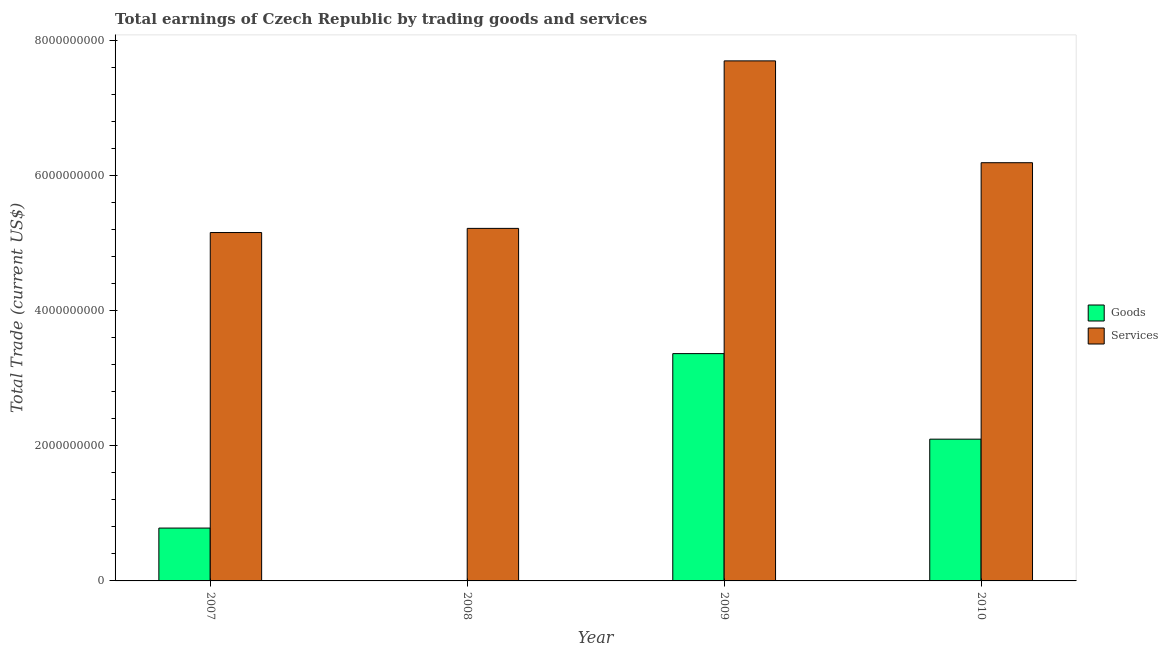How many different coloured bars are there?
Offer a very short reply. 2. Are the number of bars per tick equal to the number of legend labels?
Provide a short and direct response. No. Are the number of bars on each tick of the X-axis equal?
Ensure brevity in your answer.  No. How many bars are there on the 4th tick from the left?
Your answer should be very brief. 2. How many bars are there on the 3rd tick from the right?
Provide a succinct answer. 1. What is the amount earned by trading services in 2010?
Give a very brief answer. 6.19e+09. Across all years, what is the maximum amount earned by trading goods?
Your answer should be compact. 3.37e+09. Across all years, what is the minimum amount earned by trading services?
Make the answer very short. 5.16e+09. What is the total amount earned by trading services in the graph?
Keep it short and to the point. 2.43e+1. What is the difference between the amount earned by trading services in 2007 and that in 2010?
Give a very brief answer. -1.03e+09. What is the difference between the amount earned by trading goods in 2008 and the amount earned by trading services in 2009?
Offer a terse response. -3.37e+09. What is the average amount earned by trading services per year?
Keep it short and to the point. 6.07e+09. In how many years, is the amount earned by trading goods greater than 6000000000 US$?
Provide a succinct answer. 0. What is the ratio of the amount earned by trading services in 2007 to that in 2010?
Your response must be concise. 0.83. What is the difference between the highest and the second highest amount earned by trading goods?
Make the answer very short. 1.27e+09. What is the difference between the highest and the lowest amount earned by trading services?
Your response must be concise. 2.54e+09. In how many years, is the amount earned by trading goods greater than the average amount earned by trading goods taken over all years?
Offer a terse response. 2. Is the sum of the amount earned by trading services in 2007 and 2009 greater than the maximum amount earned by trading goods across all years?
Your answer should be compact. Yes. How many years are there in the graph?
Make the answer very short. 4. What is the difference between two consecutive major ticks on the Y-axis?
Ensure brevity in your answer.  2.00e+09. Are the values on the major ticks of Y-axis written in scientific E-notation?
Your response must be concise. No. Does the graph contain any zero values?
Your answer should be compact. Yes. What is the title of the graph?
Ensure brevity in your answer.  Total earnings of Czech Republic by trading goods and services. Does "Investment in Telecom" appear as one of the legend labels in the graph?
Offer a terse response. No. What is the label or title of the X-axis?
Provide a succinct answer. Year. What is the label or title of the Y-axis?
Your response must be concise. Total Trade (current US$). What is the Total Trade (current US$) in Goods in 2007?
Your response must be concise. 7.83e+08. What is the Total Trade (current US$) in Services in 2007?
Provide a short and direct response. 5.16e+09. What is the Total Trade (current US$) in Services in 2008?
Give a very brief answer. 5.22e+09. What is the Total Trade (current US$) in Goods in 2009?
Offer a very short reply. 3.37e+09. What is the Total Trade (current US$) of Services in 2009?
Your answer should be compact. 7.70e+09. What is the Total Trade (current US$) in Goods in 2010?
Your answer should be very brief. 2.10e+09. What is the Total Trade (current US$) in Services in 2010?
Ensure brevity in your answer.  6.19e+09. Across all years, what is the maximum Total Trade (current US$) in Goods?
Make the answer very short. 3.37e+09. Across all years, what is the maximum Total Trade (current US$) of Services?
Your response must be concise. 7.70e+09. Across all years, what is the minimum Total Trade (current US$) in Goods?
Make the answer very short. 0. Across all years, what is the minimum Total Trade (current US$) in Services?
Your answer should be compact. 5.16e+09. What is the total Total Trade (current US$) of Goods in the graph?
Give a very brief answer. 6.25e+09. What is the total Total Trade (current US$) in Services in the graph?
Give a very brief answer. 2.43e+1. What is the difference between the Total Trade (current US$) of Services in 2007 and that in 2008?
Make the answer very short. -6.16e+07. What is the difference between the Total Trade (current US$) in Goods in 2007 and that in 2009?
Offer a terse response. -2.58e+09. What is the difference between the Total Trade (current US$) in Services in 2007 and that in 2009?
Your response must be concise. -2.54e+09. What is the difference between the Total Trade (current US$) of Goods in 2007 and that in 2010?
Offer a terse response. -1.32e+09. What is the difference between the Total Trade (current US$) in Services in 2007 and that in 2010?
Your answer should be very brief. -1.03e+09. What is the difference between the Total Trade (current US$) in Services in 2008 and that in 2009?
Keep it short and to the point. -2.48e+09. What is the difference between the Total Trade (current US$) of Services in 2008 and that in 2010?
Your response must be concise. -9.72e+08. What is the difference between the Total Trade (current US$) of Goods in 2009 and that in 2010?
Keep it short and to the point. 1.27e+09. What is the difference between the Total Trade (current US$) in Services in 2009 and that in 2010?
Offer a very short reply. 1.51e+09. What is the difference between the Total Trade (current US$) of Goods in 2007 and the Total Trade (current US$) of Services in 2008?
Provide a succinct answer. -4.44e+09. What is the difference between the Total Trade (current US$) in Goods in 2007 and the Total Trade (current US$) in Services in 2009?
Provide a succinct answer. -6.92e+09. What is the difference between the Total Trade (current US$) of Goods in 2007 and the Total Trade (current US$) of Services in 2010?
Your answer should be compact. -5.41e+09. What is the difference between the Total Trade (current US$) in Goods in 2009 and the Total Trade (current US$) in Services in 2010?
Provide a short and direct response. -2.83e+09. What is the average Total Trade (current US$) in Goods per year?
Ensure brevity in your answer.  1.56e+09. What is the average Total Trade (current US$) of Services per year?
Offer a very short reply. 6.07e+09. In the year 2007, what is the difference between the Total Trade (current US$) in Goods and Total Trade (current US$) in Services?
Keep it short and to the point. -4.38e+09. In the year 2009, what is the difference between the Total Trade (current US$) of Goods and Total Trade (current US$) of Services?
Provide a succinct answer. -4.33e+09. In the year 2010, what is the difference between the Total Trade (current US$) of Goods and Total Trade (current US$) of Services?
Give a very brief answer. -4.09e+09. What is the ratio of the Total Trade (current US$) of Services in 2007 to that in 2008?
Offer a terse response. 0.99. What is the ratio of the Total Trade (current US$) in Goods in 2007 to that in 2009?
Keep it short and to the point. 0.23. What is the ratio of the Total Trade (current US$) in Services in 2007 to that in 2009?
Offer a terse response. 0.67. What is the ratio of the Total Trade (current US$) of Goods in 2007 to that in 2010?
Provide a succinct answer. 0.37. What is the ratio of the Total Trade (current US$) of Services in 2007 to that in 2010?
Your response must be concise. 0.83. What is the ratio of the Total Trade (current US$) in Services in 2008 to that in 2009?
Your answer should be compact. 0.68. What is the ratio of the Total Trade (current US$) of Services in 2008 to that in 2010?
Make the answer very short. 0.84. What is the ratio of the Total Trade (current US$) of Goods in 2009 to that in 2010?
Provide a short and direct response. 1.6. What is the ratio of the Total Trade (current US$) in Services in 2009 to that in 2010?
Ensure brevity in your answer.  1.24. What is the difference between the highest and the second highest Total Trade (current US$) in Goods?
Ensure brevity in your answer.  1.27e+09. What is the difference between the highest and the second highest Total Trade (current US$) of Services?
Ensure brevity in your answer.  1.51e+09. What is the difference between the highest and the lowest Total Trade (current US$) in Goods?
Keep it short and to the point. 3.37e+09. What is the difference between the highest and the lowest Total Trade (current US$) in Services?
Your answer should be very brief. 2.54e+09. 